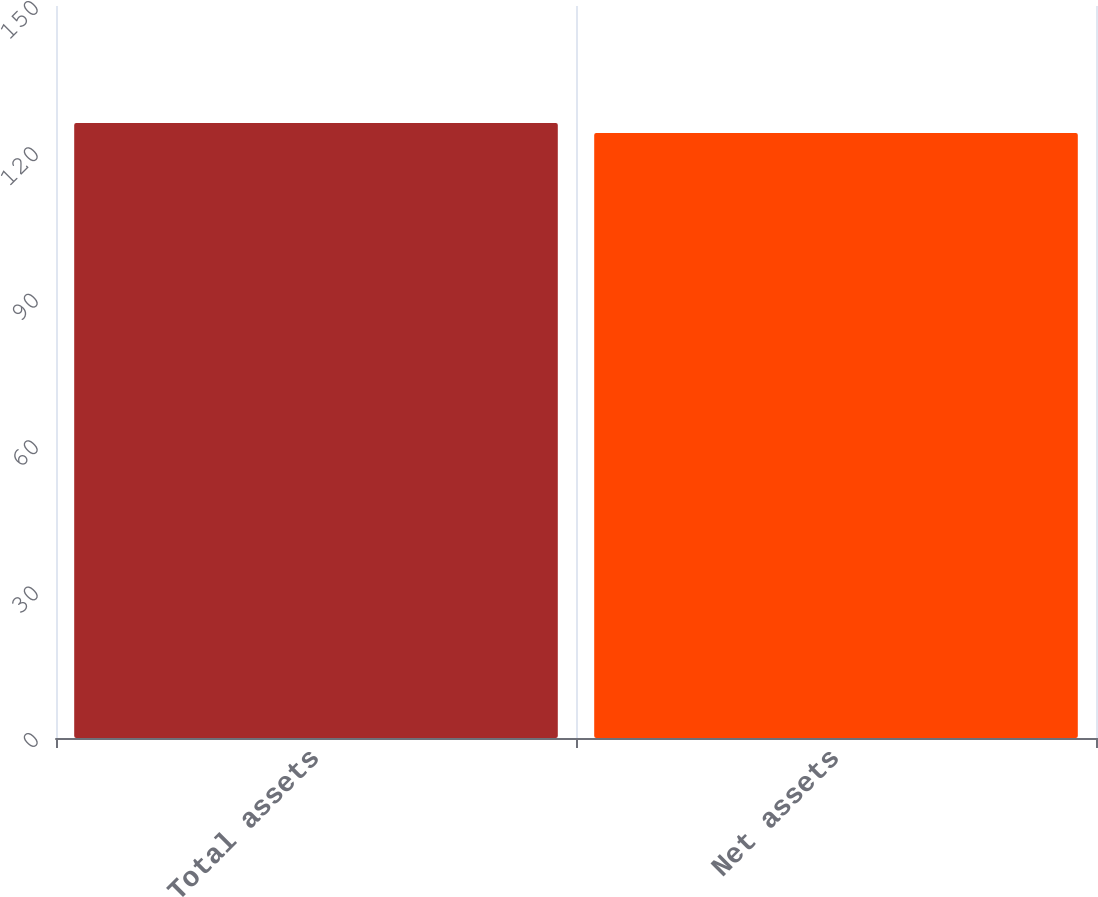Convert chart to OTSL. <chart><loc_0><loc_0><loc_500><loc_500><bar_chart><fcel>Total assets<fcel>Net assets<nl><fcel>126<fcel>124<nl></chart> 